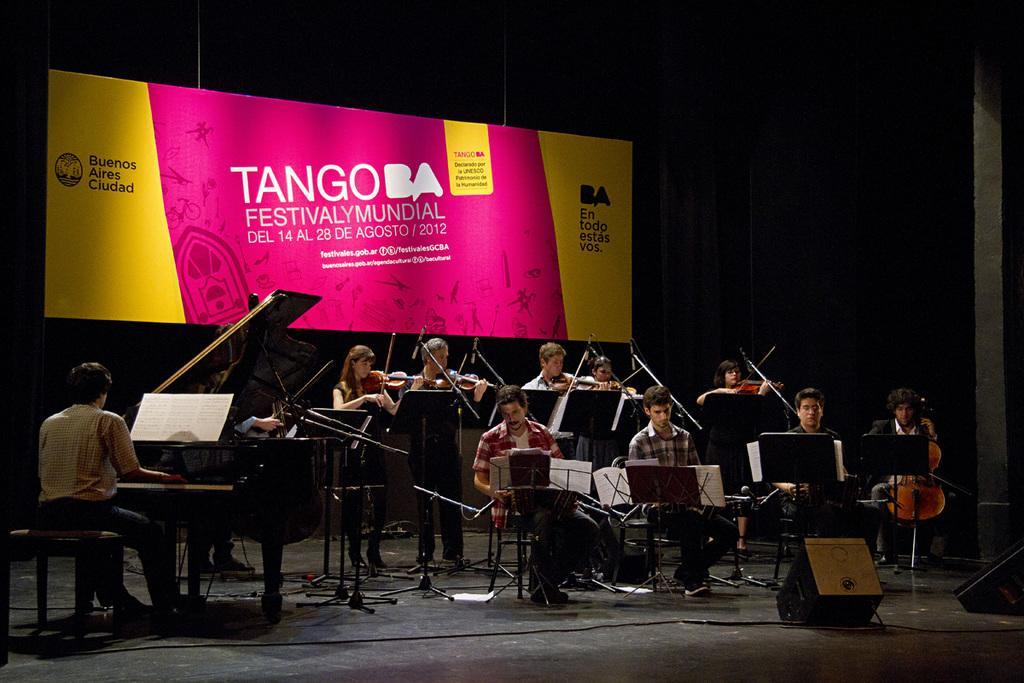Please provide a concise description of this image. In the image we can see there are people sitting on the chairs and there are people standing. There are mice kept on the stand and there are people playing musical instruments. There is a piano and there is a person sitting on the chair. There are speaker boxes kept on the stage and behind there is a banner. 